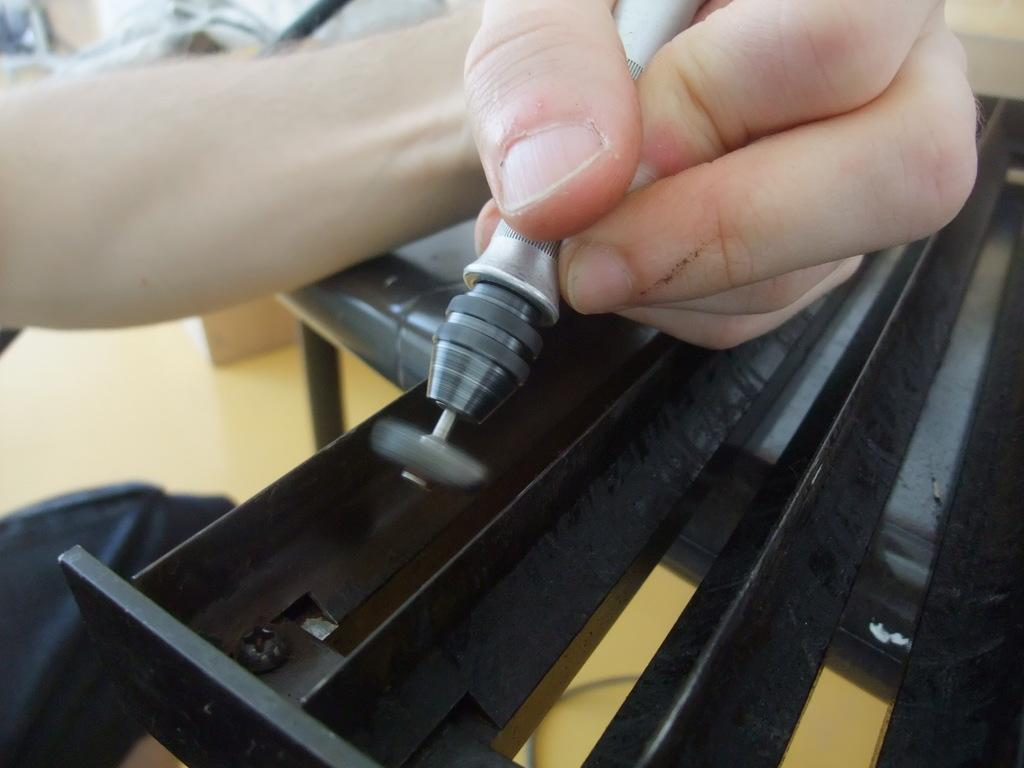What is the person in the image holding? The person is holding a tool in the image. Can you describe the appearance of the tool? The tool has grey and silver colors. What other object can be seen in the image? There is a black color iron rod in the image. What is the color of the floor in the background? The floor in the background has a brown color. Can you see any mountains in the image? There are no mountains visible in the image. Is the person in the image offering something to someone? There is no indication in the image that the person is offering something to someone. 